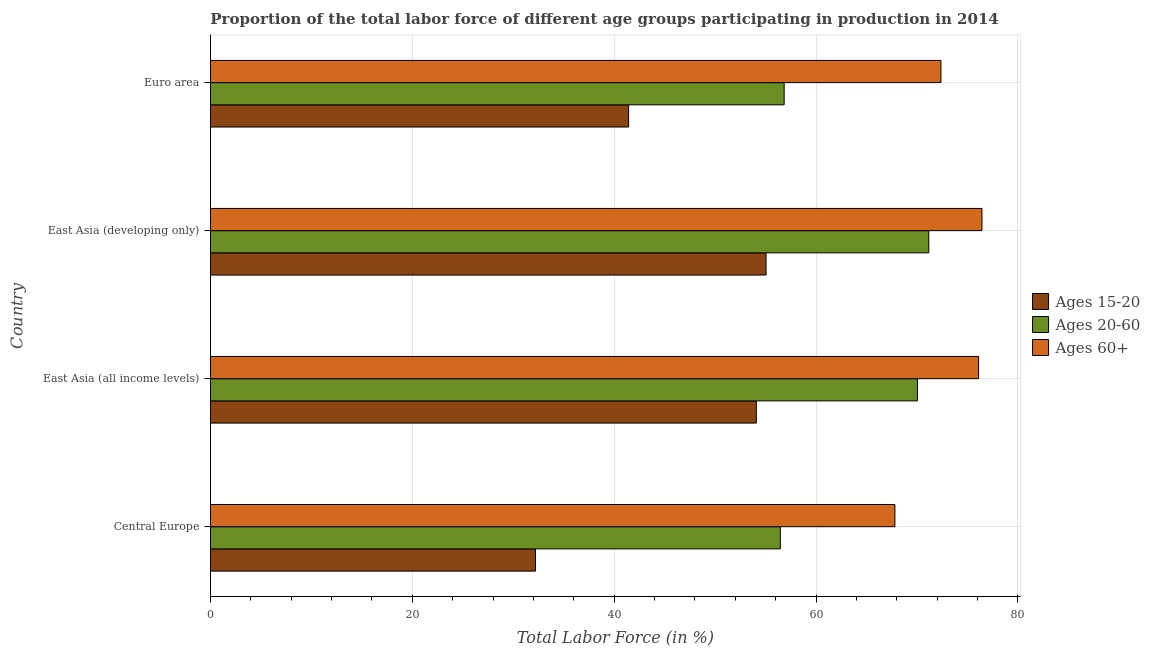How many bars are there on the 4th tick from the top?
Provide a short and direct response. 3. In how many cases, is the number of bars for a given country not equal to the number of legend labels?
Your answer should be compact. 0. What is the percentage of labor force within the age group 20-60 in Euro area?
Your response must be concise. 56.84. Across all countries, what is the maximum percentage of labor force within the age group 15-20?
Ensure brevity in your answer.  55.04. Across all countries, what is the minimum percentage of labor force within the age group 20-60?
Provide a succinct answer. 56.46. In which country was the percentage of labor force within the age group 15-20 maximum?
Make the answer very short. East Asia (developing only). In which country was the percentage of labor force within the age group 15-20 minimum?
Your response must be concise. Central Europe. What is the total percentage of labor force within the age group 20-60 in the graph?
Offer a very short reply. 254.49. What is the difference between the percentage of labor force above age 60 in Central Europe and that in East Asia (all income levels)?
Your answer should be very brief. -8.29. What is the difference between the percentage of labor force within the age group 20-60 in Euro area and the percentage of labor force within the age group 15-20 in East Asia (developing only)?
Offer a very short reply. 1.8. What is the average percentage of labor force above age 60 per country?
Give a very brief answer. 73.18. What is the difference between the percentage of labor force within the age group 15-20 and percentage of labor force above age 60 in East Asia (developing only)?
Offer a terse response. -21.39. What is the ratio of the percentage of labor force within the age group 15-20 in Central Europe to that in East Asia (developing only)?
Your answer should be very brief. 0.58. Is the percentage of labor force above age 60 in Central Europe less than that in East Asia (developing only)?
Keep it short and to the point. Yes. Is the difference between the percentage of labor force within the age group 20-60 in East Asia (all income levels) and Euro area greater than the difference between the percentage of labor force above age 60 in East Asia (all income levels) and Euro area?
Your response must be concise. Yes. What is the difference between the highest and the second highest percentage of labor force above age 60?
Offer a very short reply. 0.34. What is the difference between the highest and the lowest percentage of labor force within the age group 15-20?
Keep it short and to the point. 22.84. Is the sum of the percentage of labor force above age 60 in Central Europe and Euro area greater than the maximum percentage of labor force within the age group 20-60 across all countries?
Offer a very short reply. Yes. What does the 2nd bar from the top in Central Europe represents?
Give a very brief answer. Ages 20-60. What does the 2nd bar from the bottom in Euro area represents?
Give a very brief answer. Ages 20-60. How many bars are there?
Offer a terse response. 12. Are all the bars in the graph horizontal?
Keep it short and to the point. Yes. How many countries are there in the graph?
Your response must be concise. 4. Are the values on the major ticks of X-axis written in scientific E-notation?
Offer a terse response. No. Does the graph contain grids?
Keep it short and to the point. Yes. How are the legend labels stacked?
Offer a very short reply. Vertical. What is the title of the graph?
Your answer should be compact. Proportion of the total labor force of different age groups participating in production in 2014. Does "Other sectors" appear as one of the legend labels in the graph?
Ensure brevity in your answer.  No. What is the label or title of the X-axis?
Offer a terse response. Total Labor Force (in %). What is the label or title of the Y-axis?
Offer a terse response. Country. What is the Total Labor Force (in %) in Ages 15-20 in Central Europe?
Your answer should be very brief. 32.2. What is the Total Labor Force (in %) of Ages 20-60 in Central Europe?
Offer a terse response. 56.46. What is the Total Labor Force (in %) in Ages 60+ in Central Europe?
Provide a succinct answer. 67.81. What is the Total Labor Force (in %) in Ages 15-20 in East Asia (all income levels)?
Offer a very short reply. 54.08. What is the Total Labor Force (in %) in Ages 20-60 in East Asia (all income levels)?
Your answer should be very brief. 70.04. What is the Total Labor Force (in %) in Ages 60+ in East Asia (all income levels)?
Make the answer very short. 76.1. What is the Total Labor Force (in %) in Ages 15-20 in East Asia (developing only)?
Offer a terse response. 55.04. What is the Total Labor Force (in %) of Ages 20-60 in East Asia (developing only)?
Your answer should be very brief. 71.16. What is the Total Labor Force (in %) in Ages 60+ in East Asia (developing only)?
Provide a short and direct response. 76.43. What is the Total Labor Force (in %) in Ages 15-20 in Euro area?
Ensure brevity in your answer.  41.43. What is the Total Labor Force (in %) of Ages 20-60 in Euro area?
Offer a terse response. 56.84. What is the Total Labor Force (in %) of Ages 60+ in Euro area?
Provide a succinct answer. 72.37. Across all countries, what is the maximum Total Labor Force (in %) of Ages 15-20?
Provide a short and direct response. 55.04. Across all countries, what is the maximum Total Labor Force (in %) of Ages 20-60?
Your answer should be very brief. 71.16. Across all countries, what is the maximum Total Labor Force (in %) of Ages 60+?
Provide a short and direct response. 76.43. Across all countries, what is the minimum Total Labor Force (in %) in Ages 15-20?
Provide a short and direct response. 32.2. Across all countries, what is the minimum Total Labor Force (in %) in Ages 20-60?
Your answer should be very brief. 56.46. Across all countries, what is the minimum Total Labor Force (in %) of Ages 60+?
Offer a terse response. 67.81. What is the total Total Labor Force (in %) of Ages 15-20 in the graph?
Your answer should be very brief. 182.74. What is the total Total Labor Force (in %) of Ages 20-60 in the graph?
Keep it short and to the point. 254.49. What is the total Total Labor Force (in %) in Ages 60+ in the graph?
Your answer should be very brief. 292.7. What is the difference between the Total Labor Force (in %) in Ages 15-20 in Central Europe and that in East Asia (all income levels)?
Offer a terse response. -21.88. What is the difference between the Total Labor Force (in %) of Ages 20-60 in Central Europe and that in East Asia (all income levels)?
Your response must be concise. -13.58. What is the difference between the Total Labor Force (in %) in Ages 60+ in Central Europe and that in East Asia (all income levels)?
Give a very brief answer. -8.29. What is the difference between the Total Labor Force (in %) in Ages 15-20 in Central Europe and that in East Asia (developing only)?
Provide a succinct answer. -22.84. What is the difference between the Total Labor Force (in %) of Ages 20-60 in Central Europe and that in East Asia (developing only)?
Offer a very short reply. -14.71. What is the difference between the Total Labor Force (in %) in Ages 60+ in Central Europe and that in East Asia (developing only)?
Your response must be concise. -8.63. What is the difference between the Total Labor Force (in %) of Ages 15-20 in Central Europe and that in Euro area?
Your answer should be very brief. -9.23. What is the difference between the Total Labor Force (in %) of Ages 20-60 in Central Europe and that in Euro area?
Ensure brevity in your answer.  -0.38. What is the difference between the Total Labor Force (in %) in Ages 60+ in Central Europe and that in Euro area?
Offer a terse response. -4.56. What is the difference between the Total Labor Force (in %) in Ages 15-20 in East Asia (all income levels) and that in East Asia (developing only)?
Make the answer very short. -0.96. What is the difference between the Total Labor Force (in %) of Ages 20-60 in East Asia (all income levels) and that in East Asia (developing only)?
Provide a short and direct response. -1.12. What is the difference between the Total Labor Force (in %) of Ages 60+ in East Asia (all income levels) and that in East Asia (developing only)?
Your response must be concise. -0.34. What is the difference between the Total Labor Force (in %) in Ages 15-20 in East Asia (all income levels) and that in Euro area?
Your answer should be very brief. 12.65. What is the difference between the Total Labor Force (in %) in Ages 20-60 in East Asia (all income levels) and that in Euro area?
Provide a succinct answer. 13.2. What is the difference between the Total Labor Force (in %) in Ages 60+ in East Asia (all income levels) and that in Euro area?
Your answer should be very brief. 3.73. What is the difference between the Total Labor Force (in %) in Ages 15-20 in East Asia (developing only) and that in Euro area?
Your answer should be very brief. 13.61. What is the difference between the Total Labor Force (in %) in Ages 20-60 in East Asia (developing only) and that in Euro area?
Your answer should be compact. 14.33. What is the difference between the Total Labor Force (in %) in Ages 60+ in East Asia (developing only) and that in Euro area?
Keep it short and to the point. 4.07. What is the difference between the Total Labor Force (in %) in Ages 15-20 in Central Europe and the Total Labor Force (in %) in Ages 20-60 in East Asia (all income levels)?
Your answer should be very brief. -37.84. What is the difference between the Total Labor Force (in %) of Ages 15-20 in Central Europe and the Total Labor Force (in %) of Ages 60+ in East Asia (all income levels)?
Provide a short and direct response. -43.9. What is the difference between the Total Labor Force (in %) in Ages 20-60 in Central Europe and the Total Labor Force (in %) in Ages 60+ in East Asia (all income levels)?
Your answer should be very brief. -19.64. What is the difference between the Total Labor Force (in %) in Ages 15-20 in Central Europe and the Total Labor Force (in %) in Ages 20-60 in East Asia (developing only)?
Your answer should be compact. -38.97. What is the difference between the Total Labor Force (in %) in Ages 15-20 in Central Europe and the Total Labor Force (in %) in Ages 60+ in East Asia (developing only)?
Your response must be concise. -44.24. What is the difference between the Total Labor Force (in %) in Ages 20-60 in Central Europe and the Total Labor Force (in %) in Ages 60+ in East Asia (developing only)?
Keep it short and to the point. -19.98. What is the difference between the Total Labor Force (in %) of Ages 15-20 in Central Europe and the Total Labor Force (in %) of Ages 20-60 in Euro area?
Provide a short and direct response. -24.64. What is the difference between the Total Labor Force (in %) in Ages 15-20 in Central Europe and the Total Labor Force (in %) in Ages 60+ in Euro area?
Your response must be concise. -40.17. What is the difference between the Total Labor Force (in %) in Ages 20-60 in Central Europe and the Total Labor Force (in %) in Ages 60+ in Euro area?
Ensure brevity in your answer.  -15.91. What is the difference between the Total Labor Force (in %) in Ages 15-20 in East Asia (all income levels) and the Total Labor Force (in %) in Ages 20-60 in East Asia (developing only)?
Your answer should be compact. -17.08. What is the difference between the Total Labor Force (in %) of Ages 15-20 in East Asia (all income levels) and the Total Labor Force (in %) of Ages 60+ in East Asia (developing only)?
Provide a short and direct response. -22.35. What is the difference between the Total Labor Force (in %) in Ages 20-60 in East Asia (all income levels) and the Total Labor Force (in %) in Ages 60+ in East Asia (developing only)?
Keep it short and to the point. -6.39. What is the difference between the Total Labor Force (in %) of Ages 15-20 in East Asia (all income levels) and the Total Labor Force (in %) of Ages 20-60 in Euro area?
Offer a very short reply. -2.76. What is the difference between the Total Labor Force (in %) in Ages 15-20 in East Asia (all income levels) and the Total Labor Force (in %) in Ages 60+ in Euro area?
Give a very brief answer. -18.29. What is the difference between the Total Labor Force (in %) in Ages 20-60 in East Asia (all income levels) and the Total Labor Force (in %) in Ages 60+ in Euro area?
Give a very brief answer. -2.33. What is the difference between the Total Labor Force (in %) of Ages 15-20 in East Asia (developing only) and the Total Labor Force (in %) of Ages 20-60 in Euro area?
Provide a succinct answer. -1.8. What is the difference between the Total Labor Force (in %) of Ages 15-20 in East Asia (developing only) and the Total Labor Force (in %) of Ages 60+ in Euro area?
Make the answer very short. -17.33. What is the difference between the Total Labor Force (in %) in Ages 20-60 in East Asia (developing only) and the Total Labor Force (in %) in Ages 60+ in Euro area?
Offer a very short reply. -1.2. What is the average Total Labor Force (in %) of Ages 15-20 per country?
Offer a terse response. 45.68. What is the average Total Labor Force (in %) in Ages 20-60 per country?
Your answer should be very brief. 63.62. What is the average Total Labor Force (in %) of Ages 60+ per country?
Make the answer very short. 73.18. What is the difference between the Total Labor Force (in %) of Ages 15-20 and Total Labor Force (in %) of Ages 20-60 in Central Europe?
Your answer should be compact. -24.26. What is the difference between the Total Labor Force (in %) of Ages 15-20 and Total Labor Force (in %) of Ages 60+ in Central Europe?
Give a very brief answer. -35.61. What is the difference between the Total Labor Force (in %) of Ages 20-60 and Total Labor Force (in %) of Ages 60+ in Central Europe?
Your response must be concise. -11.35. What is the difference between the Total Labor Force (in %) of Ages 15-20 and Total Labor Force (in %) of Ages 20-60 in East Asia (all income levels)?
Ensure brevity in your answer.  -15.96. What is the difference between the Total Labor Force (in %) in Ages 15-20 and Total Labor Force (in %) in Ages 60+ in East Asia (all income levels)?
Your response must be concise. -22.02. What is the difference between the Total Labor Force (in %) of Ages 20-60 and Total Labor Force (in %) of Ages 60+ in East Asia (all income levels)?
Your answer should be very brief. -6.06. What is the difference between the Total Labor Force (in %) of Ages 15-20 and Total Labor Force (in %) of Ages 20-60 in East Asia (developing only)?
Offer a terse response. -16.12. What is the difference between the Total Labor Force (in %) in Ages 15-20 and Total Labor Force (in %) in Ages 60+ in East Asia (developing only)?
Provide a succinct answer. -21.39. What is the difference between the Total Labor Force (in %) of Ages 20-60 and Total Labor Force (in %) of Ages 60+ in East Asia (developing only)?
Keep it short and to the point. -5.27. What is the difference between the Total Labor Force (in %) of Ages 15-20 and Total Labor Force (in %) of Ages 20-60 in Euro area?
Provide a succinct answer. -15.41. What is the difference between the Total Labor Force (in %) of Ages 15-20 and Total Labor Force (in %) of Ages 60+ in Euro area?
Provide a succinct answer. -30.94. What is the difference between the Total Labor Force (in %) in Ages 20-60 and Total Labor Force (in %) in Ages 60+ in Euro area?
Make the answer very short. -15.53. What is the ratio of the Total Labor Force (in %) of Ages 15-20 in Central Europe to that in East Asia (all income levels)?
Provide a succinct answer. 0.6. What is the ratio of the Total Labor Force (in %) of Ages 20-60 in Central Europe to that in East Asia (all income levels)?
Your answer should be very brief. 0.81. What is the ratio of the Total Labor Force (in %) of Ages 60+ in Central Europe to that in East Asia (all income levels)?
Offer a terse response. 0.89. What is the ratio of the Total Labor Force (in %) in Ages 15-20 in Central Europe to that in East Asia (developing only)?
Provide a short and direct response. 0.58. What is the ratio of the Total Labor Force (in %) in Ages 20-60 in Central Europe to that in East Asia (developing only)?
Give a very brief answer. 0.79. What is the ratio of the Total Labor Force (in %) in Ages 60+ in Central Europe to that in East Asia (developing only)?
Your answer should be compact. 0.89. What is the ratio of the Total Labor Force (in %) of Ages 15-20 in Central Europe to that in Euro area?
Your answer should be very brief. 0.78. What is the ratio of the Total Labor Force (in %) in Ages 20-60 in Central Europe to that in Euro area?
Give a very brief answer. 0.99. What is the ratio of the Total Labor Force (in %) of Ages 60+ in Central Europe to that in Euro area?
Make the answer very short. 0.94. What is the ratio of the Total Labor Force (in %) of Ages 15-20 in East Asia (all income levels) to that in East Asia (developing only)?
Keep it short and to the point. 0.98. What is the ratio of the Total Labor Force (in %) of Ages 20-60 in East Asia (all income levels) to that in East Asia (developing only)?
Give a very brief answer. 0.98. What is the ratio of the Total Labor Force (in %) in Ages 15-20 in East Asia (all income levels) to that in Euro area?
Keep it short and to the point. 1.31. What is the ratio of the Total Labor Force (in %) in Ages 20-60 in East Asia (all income levels) to that in Euro area?
Ensure brevity in your answer.  1.23. What is the ratio of the Total Labor Force (in %) in Ages 60+ in East Asia (all income levels) to that in Euro area?
Provide a short and direct response. 1.05. What is the ratio of the Total Labor Force (in %) in Ages 15-20 in East Asia (developing only) to that in Euro area?
Offer a terse response. 1.33. What is the ratio of the Total Labor Force (in %) in Ages 20-60 in East Asia (developing only) to that in Euro area?
Your response must be concise. 1.25. What is the ratio of the Total Labor Force (in %) in Ages 60+ in East Asia (developing only) to that in Euro area?
Offer a very short reply. 1.06. What is the difference between the highest and the second highest Total Labor Force (in %) of Ages 15-20?
Ensure brevity in your answer.  0.96. What is the difference between the highest and the second highest Total Labor Force (in %) in Ages 20-60?
Offer a terse response. 1.12. What is the difference between the highest and the second highest Total Labor Force (in %) of Ages 60+?
Your answer should be very brief. 0.34. What is the difference between the highest and the lowest Total Labor Force (in %) of Ages 15-20?
Provide a succinct answer. 22.84. What is the difference between the highest and the lowest Total Labor Force (in %) in Ages 20-60?
Provide a succinct answer. 14.71. What is the difference between the highest and the lowest Total Labor Force (in %) of Ages 60+?
Your answer should be very brief. 8.63. 